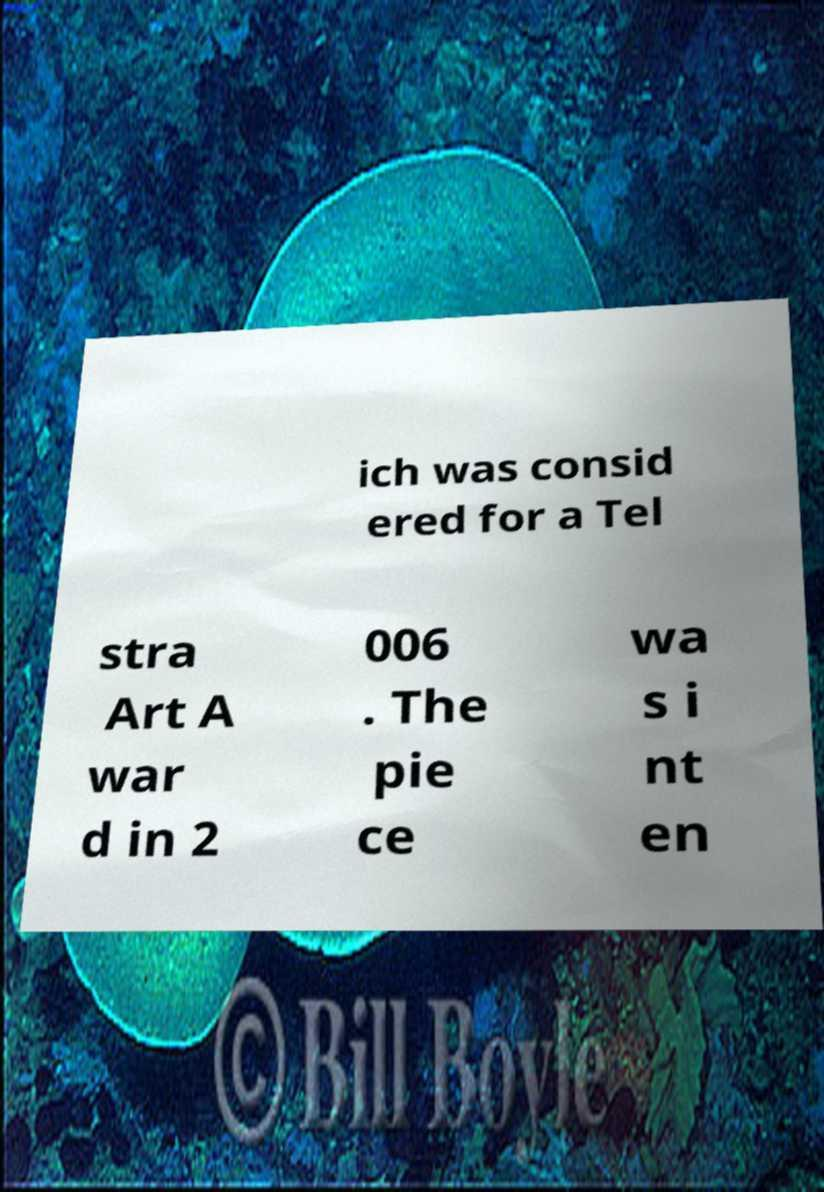Please read and relay the text visible in this image. What does it say? ich was consid ered for a Tel stra Art A war d in 2 006 . The pie ce wa s i nt en 